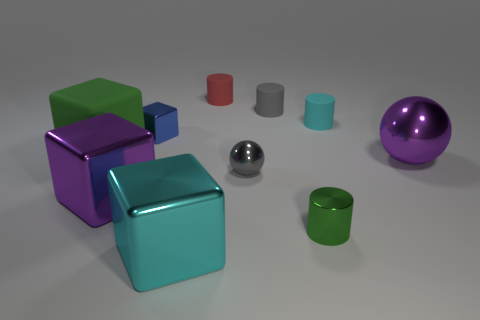How many objects are there in the image? There are a total of eight objects, consisting of various geometric shapes, in the image.  Can you describe the objects on the left side of the image? On the left side of the image, you can see three vibrant colored cubes; one is green, another is purple, and the last one is blue. 